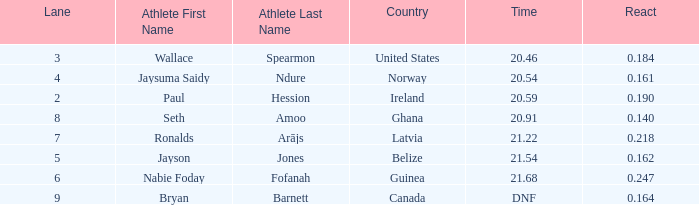Who is the athlete when react is 0.164? Bryan Barnett. 